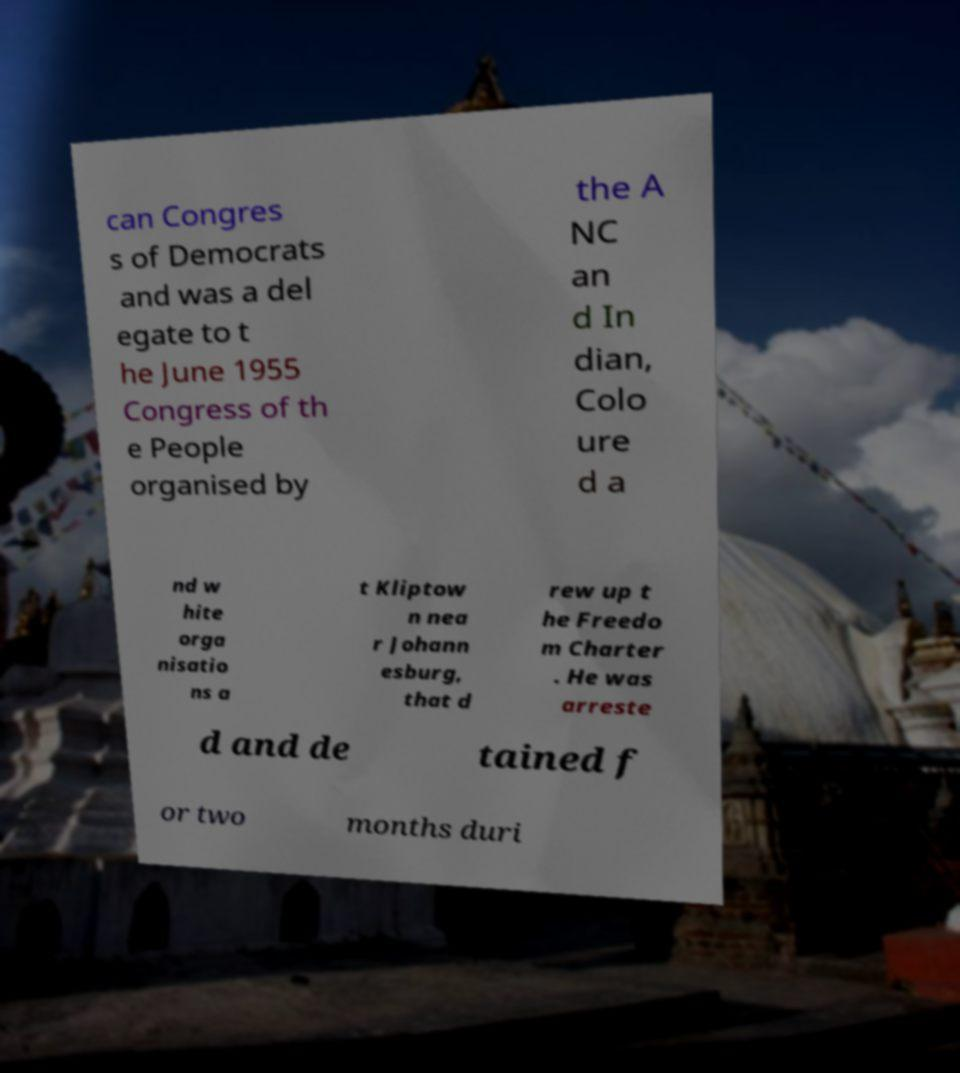Can you read and provide the text displayed in the image?This photo seems to have some interesting text. Can you extract and type it out for me? can Congres s of Democrats and was a del egate to t he June 1955 Congress of th e People organised by the A NC an d In dian, Colo ure d a nd w hite orga nisatio ns a t Kliptow n nea r Johann esburg, that d rew up t he Freedo m Charter . He was arreste d and de tained f or two months duri 